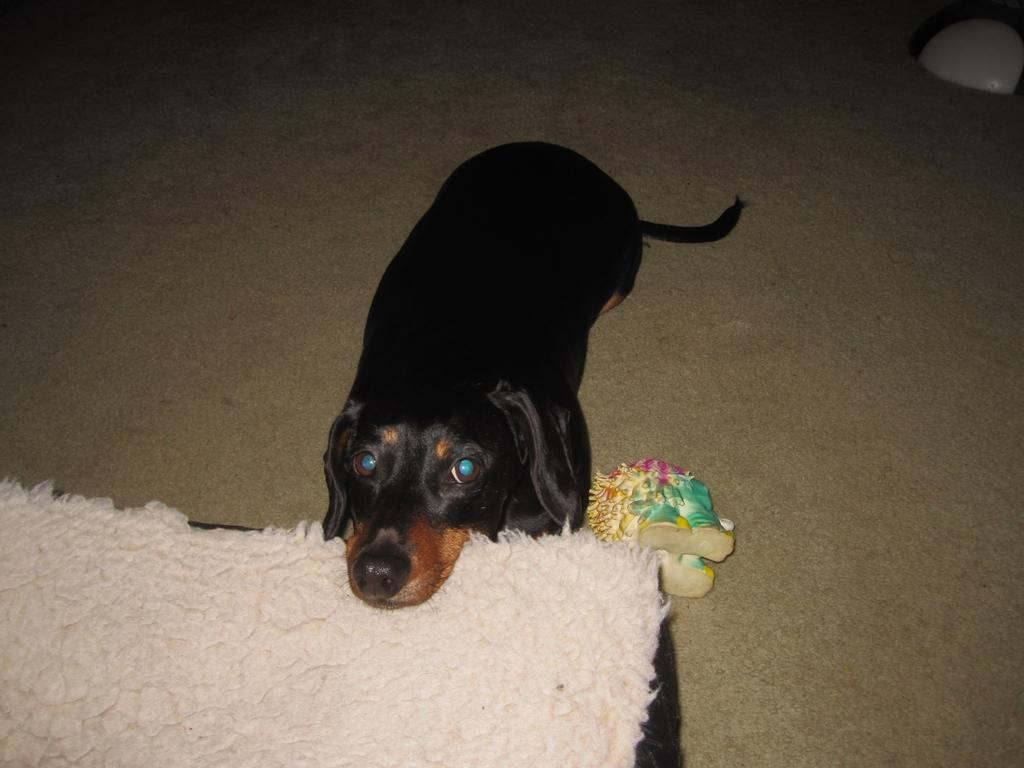What type of animal is present in the image? There is a dog in the image. What piece of furniture is visible in the image? There is a bed in the image. Can you see any cobwebs in the image? There is no mention of cobwebs in the provided facts, and therefore we cannot determine their presence in the image. 